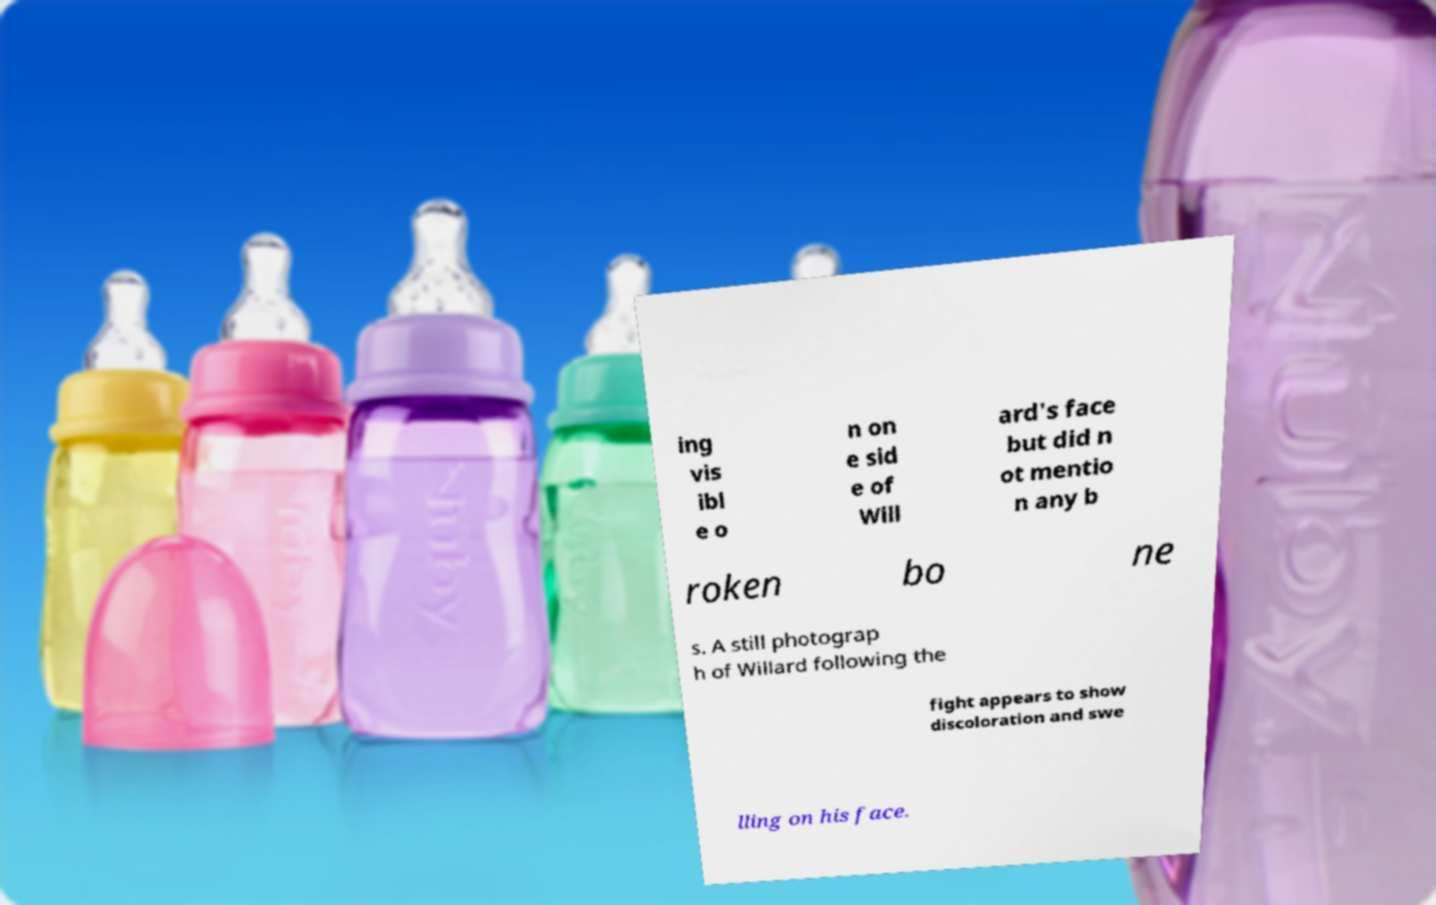What messages or text are displayed in this image? I need them in a readable, typed format. ing vis ibl e o n on e sid e of Will ard's face but did n ot mentio n any b roken bo ne s. A still photograp h of Willard following the fight appears to show discoloration and swe lling on his face. 